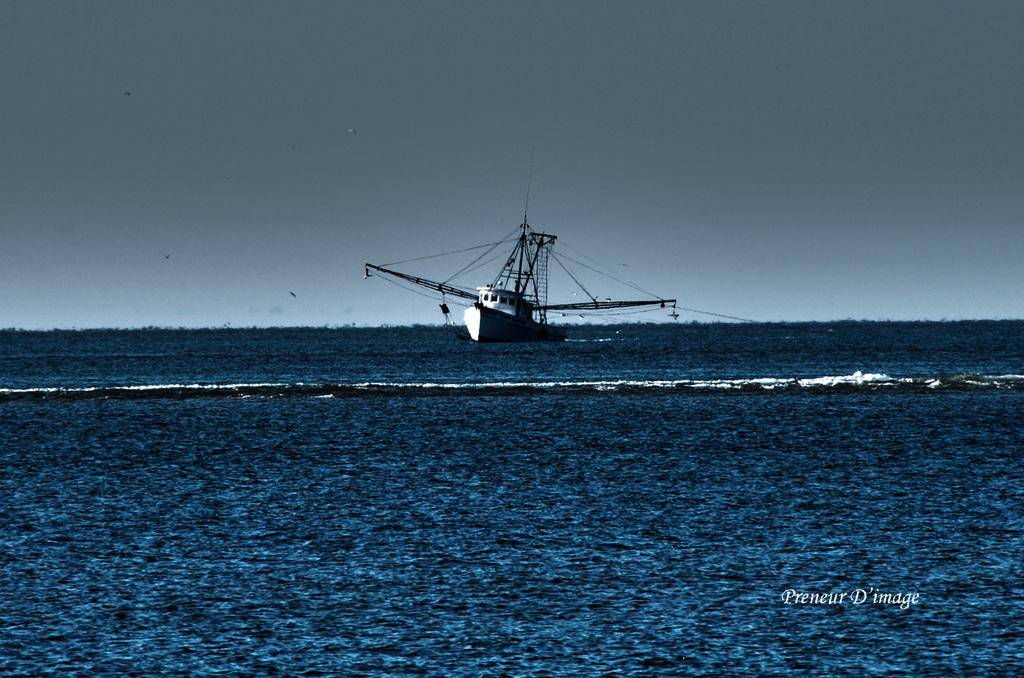What is the main subject of the image? The main subject of the image is a boat. Where is the boat located? The boat is on the water. What can be seen in the background of the image? There is sky visible in the background of the image. Is there any additional information about the image itself? Yes, there is a watermark on the image. What decision does the boat make in the image? Boats do not make decisions; they are inanimate objects. The boat in the image is simply floating on the water. 